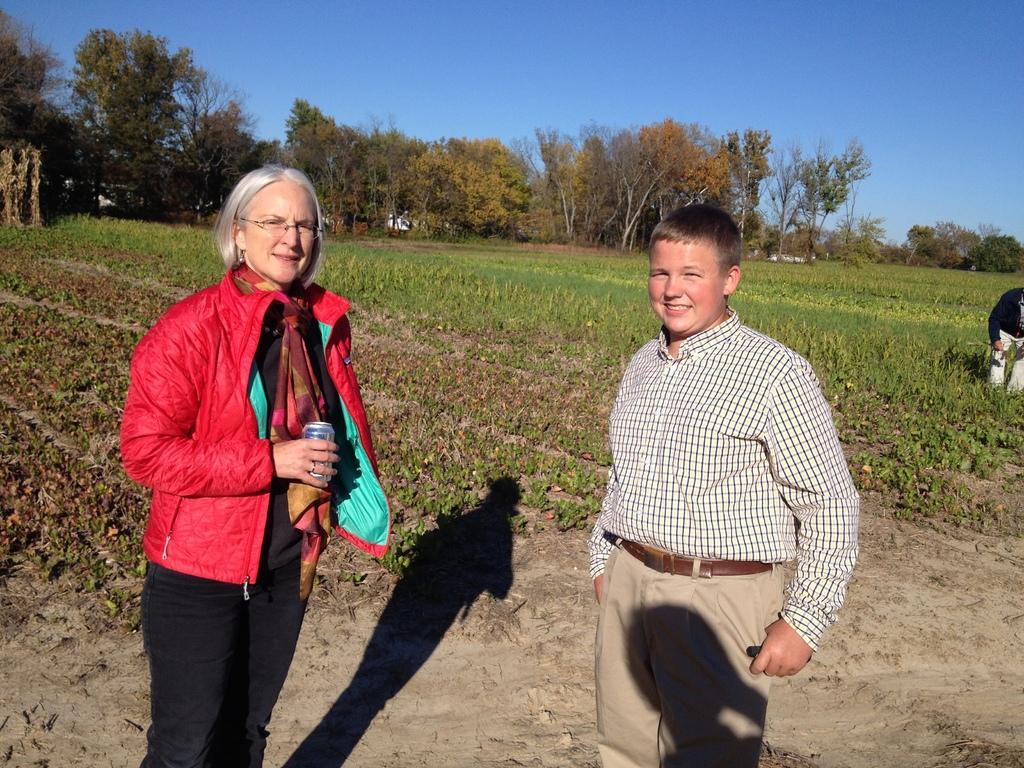Describe this image in one or two sentences. In this image we can see a man and a woman standing on the ground. In that a woman is holding a tin. On the backside we can see a person standing, some plants, a group of trees and the sky. 